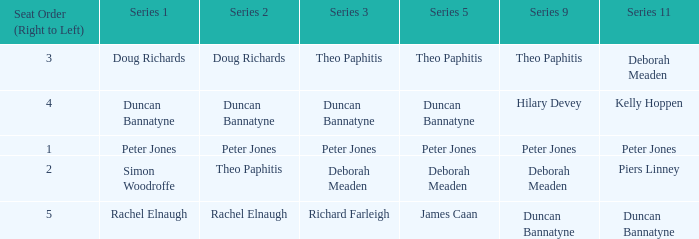Which series 2 contains a series 3 involving deborah meaden? Theo Paphitis. 